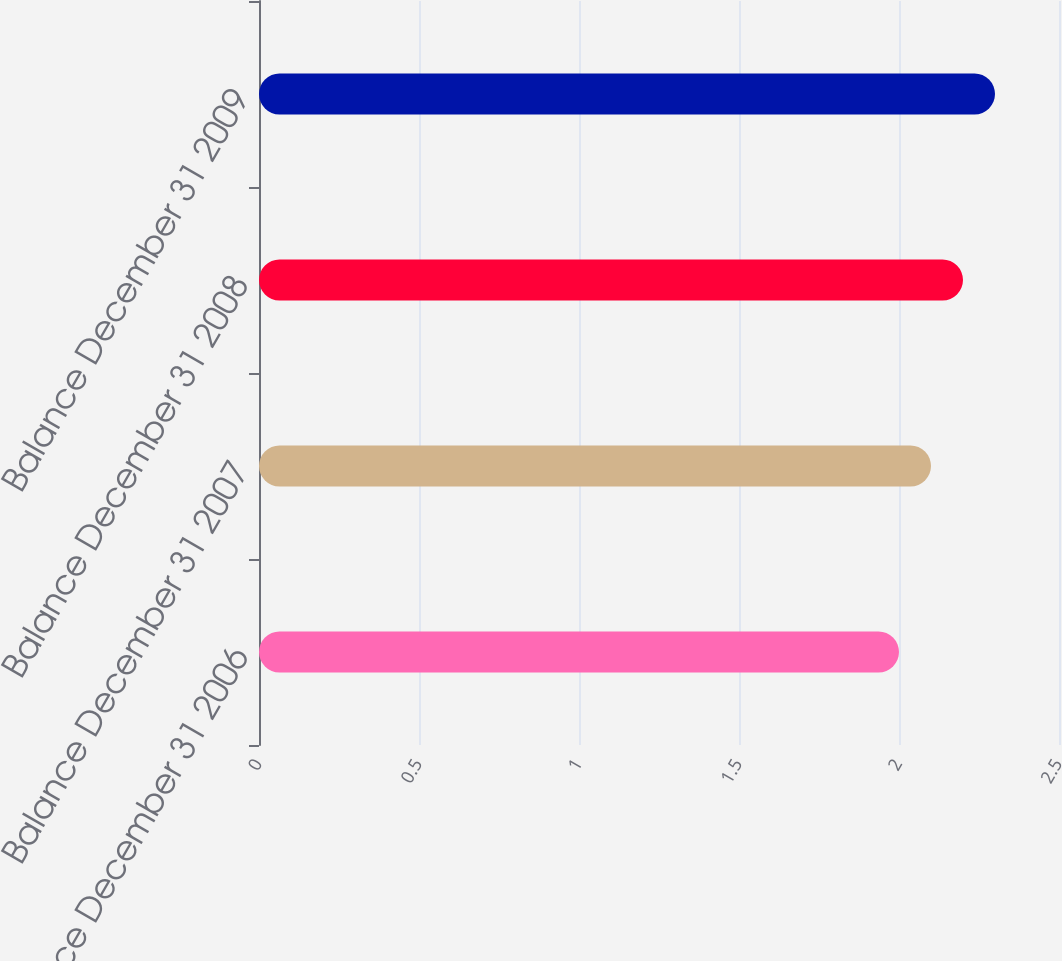Convert chart to OTSL. <chart><loc_0><loc_0><loc_500><loc_500><bar_chart><fcel>Balance December 31 2006<fcel>Balance December 31 2007<fcel>Balance December 31 2008<fcel>Balance December 31 2009<nl><fcel>2<fcel>2.1<fcel>2.2<fcel>2.3<nl></chart> 